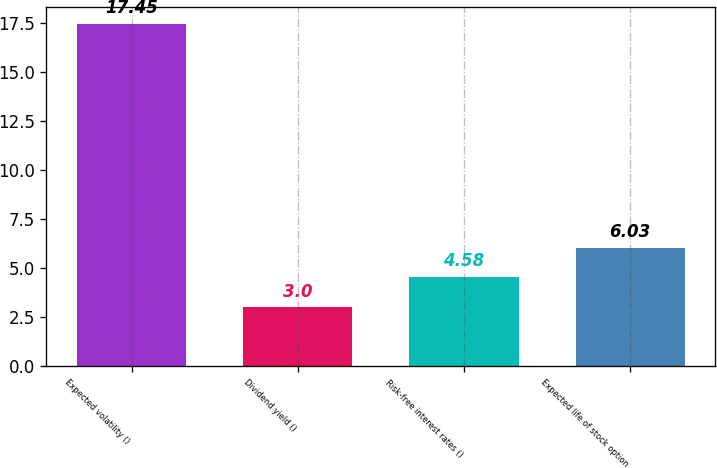Convert chart. <chart><loc_0><loc_0><loc_500><loc_500><bar_chart><fcel>Expected volatility ()<fcel>Dividend yield ()<fcel>Risk-free interest rates ()<fcel>Expected life of stock option<nl><fcel>17.45<fcel>3<fcel>4.58<fcel>6.03<nl></chart> 